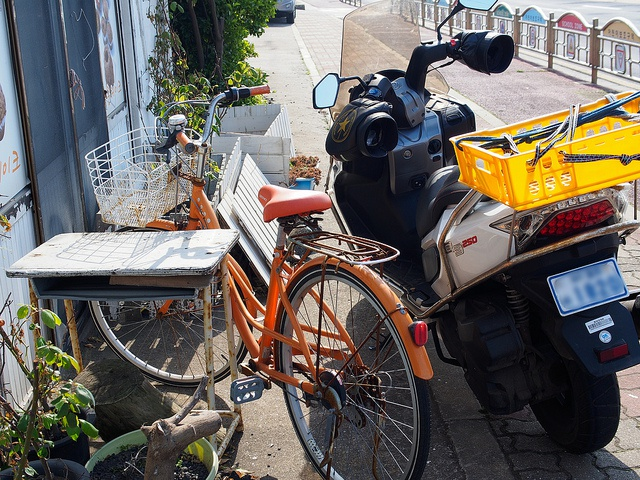Describe the objects in this image and their specific colors. I can see motorcycle in gray, black, darkgray, and maroon tones, bicycle in gray, black, darkgray, and maroon tones, and car in gray and black tones in this image. 